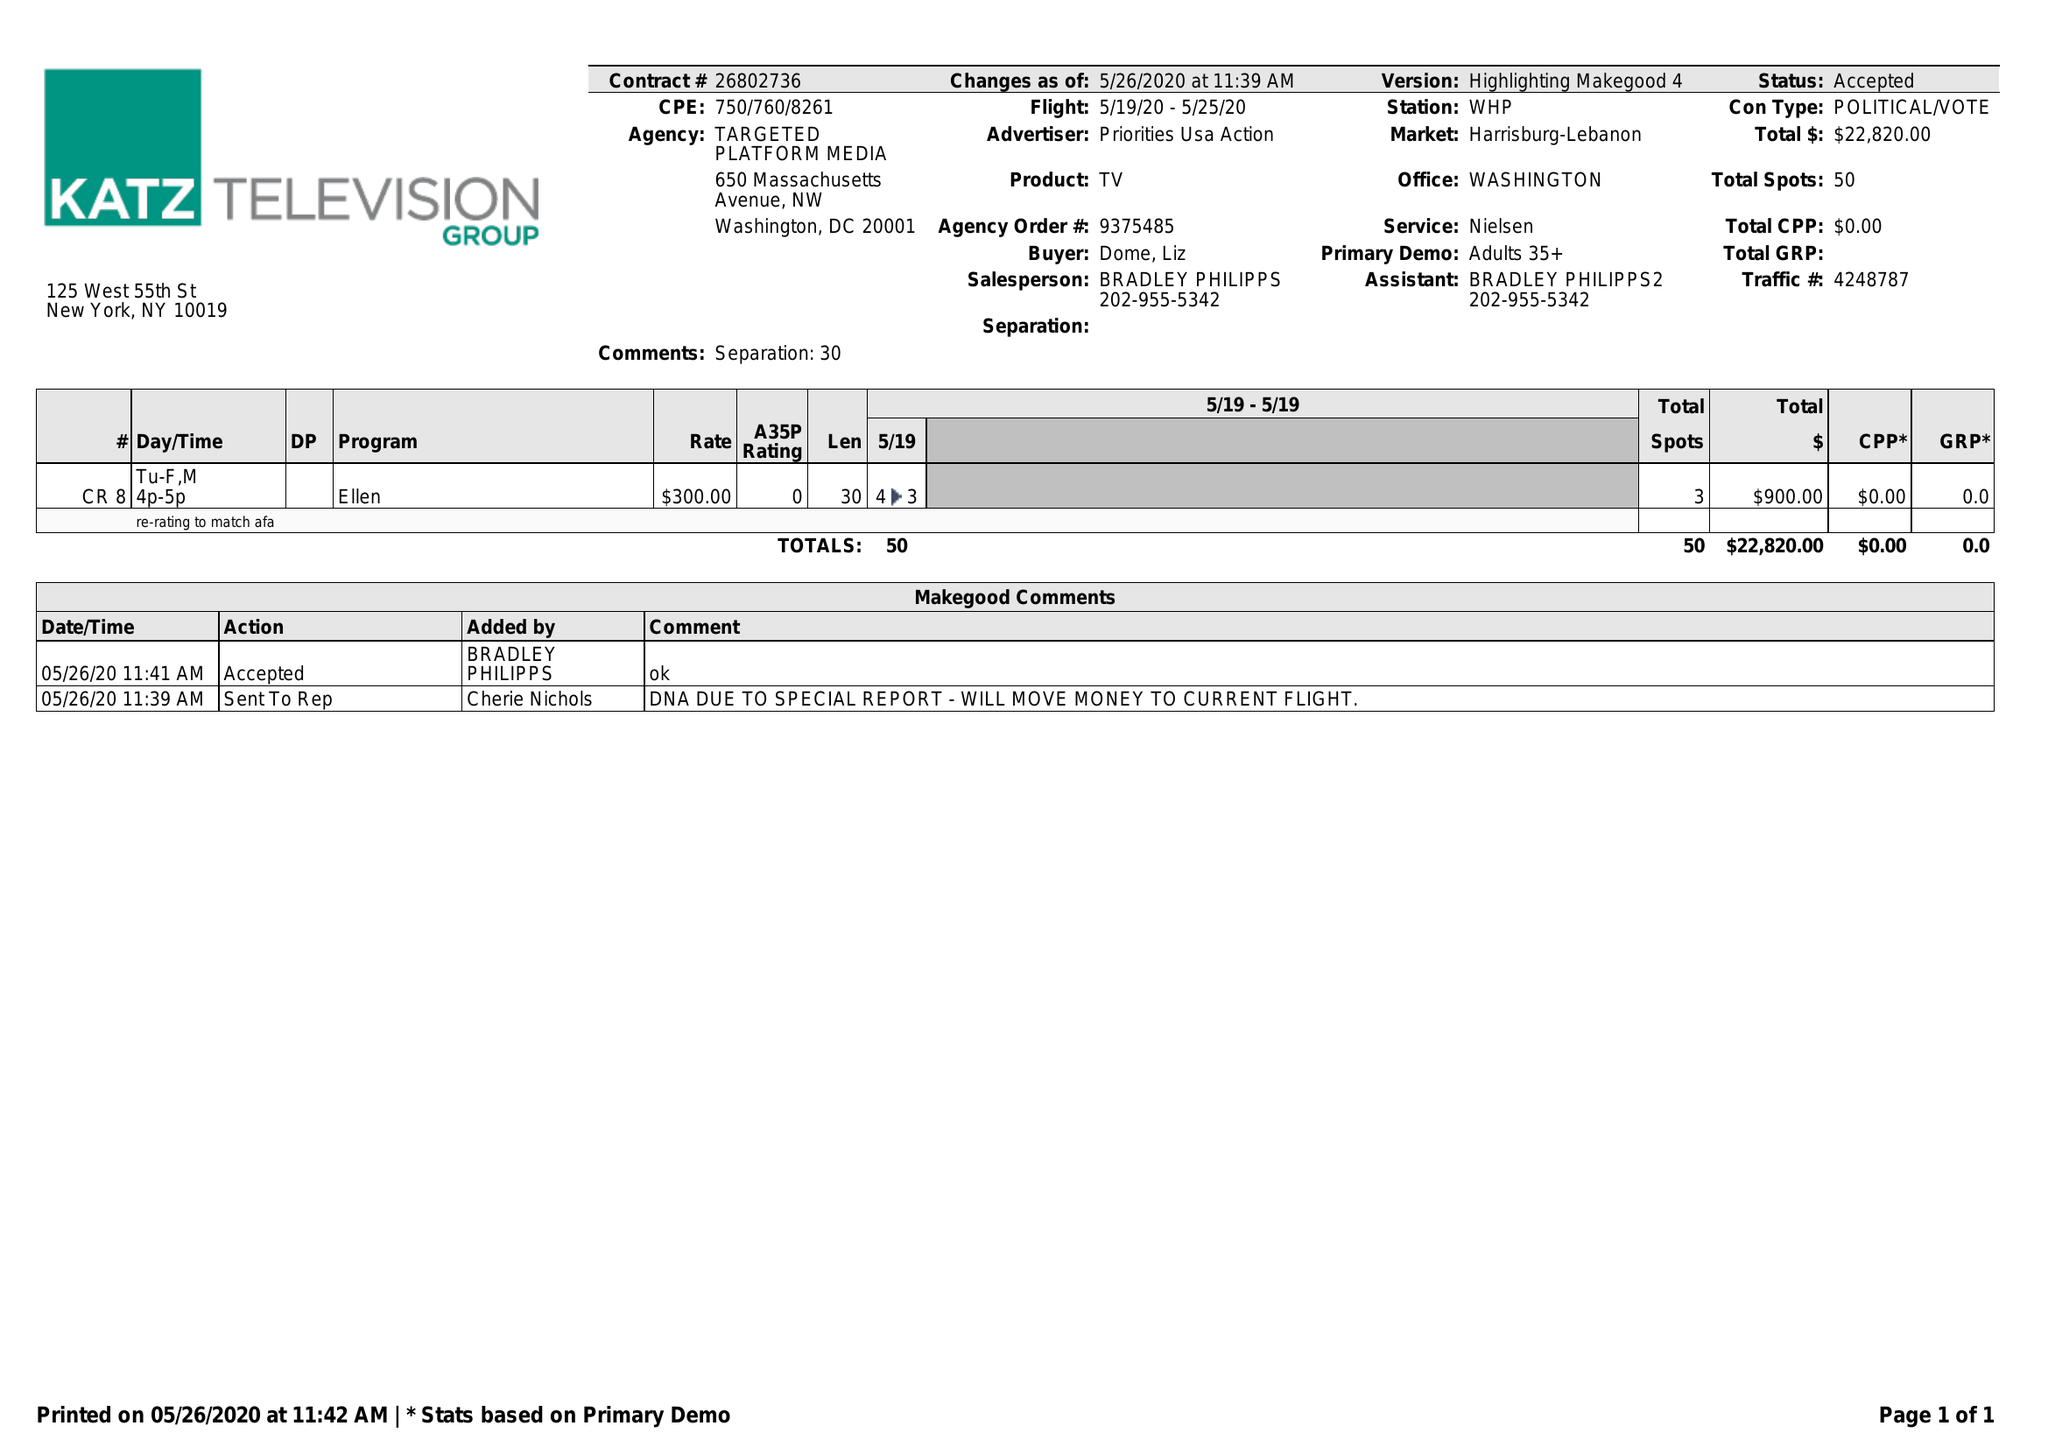What is the value for the flight_to?
Answer the question using a single word or phrase. 05/25/20 